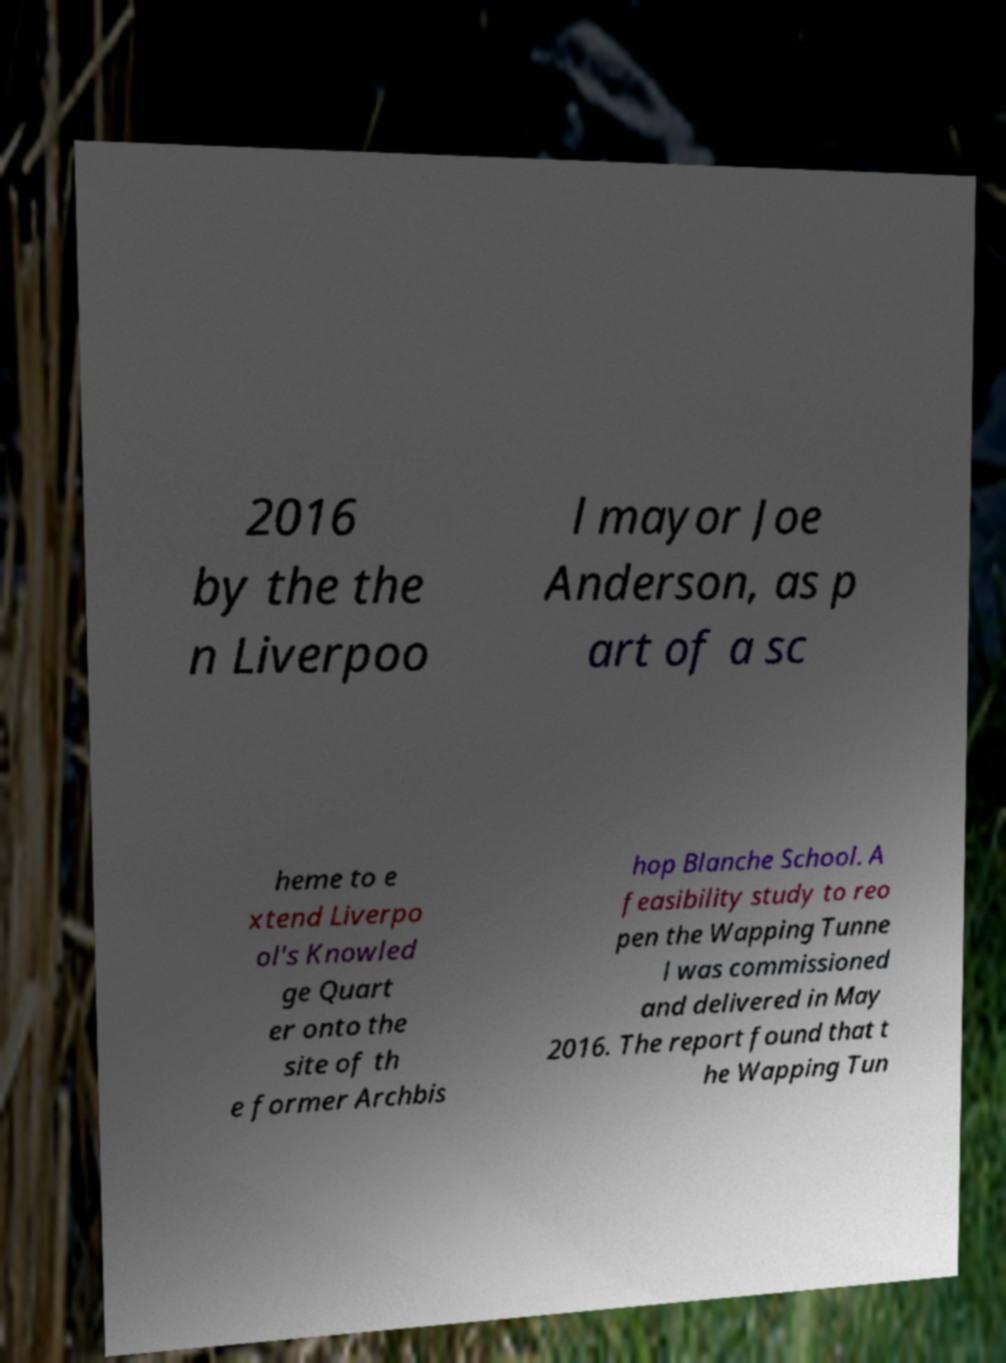There's text embedded in this image that I need extracted. Can you transcribe it verbatim? 2016 by the the n Liverpoo l mayor Joe Anderson, as p art of a sc heme to e xtend Liverpo ol's Knowled ge Quart er onto the site of th e former Archbis hop Blanche School. A feasibility study to reo pen the Wapping Tunne l was commissioned and delivered in May 2016. The report found that t he Wapping Tun 